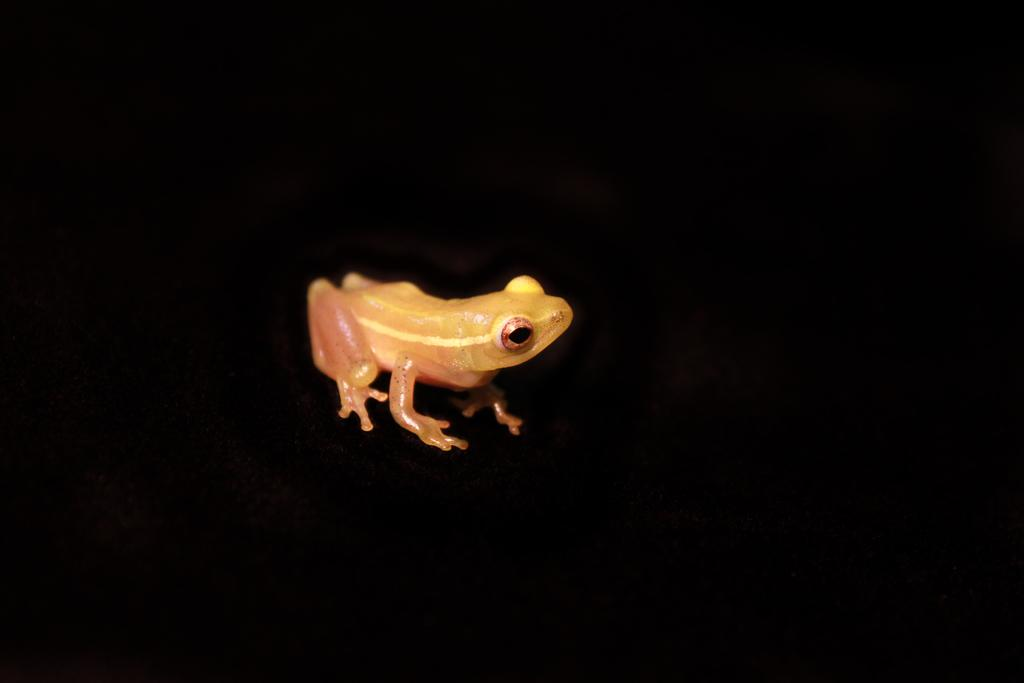What type of animal is in the image? There is a true frog in the image. What can be seen in the background of the image? The background of the image is dark. What religion is practiced by the frog in the image? There is no indication of religion in the image, as it features a true frog and a dark background. 